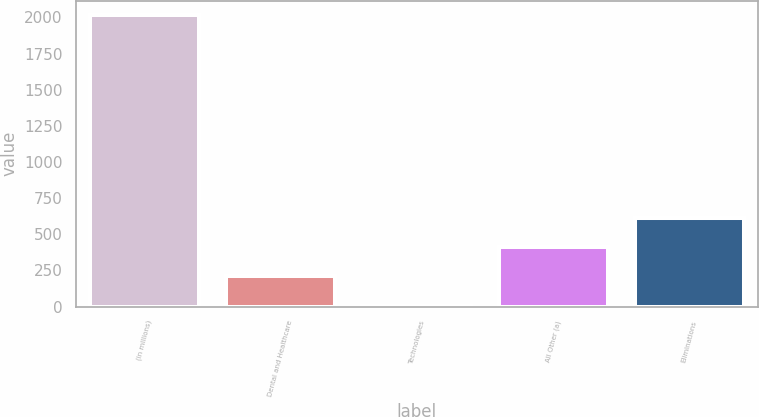Convert chart. <chart><loc_0><loc_0><loc_500><loc_500><bar_chart><fcel>(in millions)<fcel>Dental and Healthcare<fcel>Technologies<fcel>All Other (a)<fcel>Eliminations<nl><fcel>2014<fcel>210.8<fcel>6.8<fcel>411.52<fcel>612.24<nl></chart> 